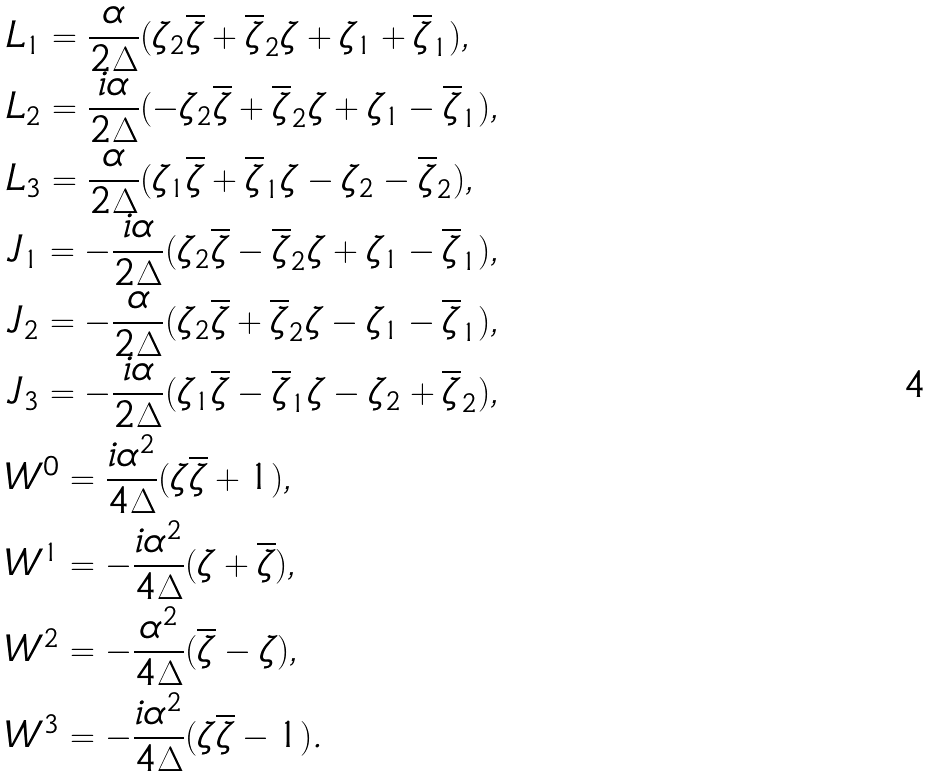<formula> <loc_0><loc_0><loc_500><loc_500>& L _ { 1 } = \frac { \alpha } { 2 \Delta } ( \zeta _ { 2 } \overline { \zeta } + \overline { \zeta } _ { 2 } \zeta + \zeta _ { 1 } + \overline { \zeta } _ { 1 } ) , \\ & L _ { 2 } = \frac { i \alpha } { 2 \Delta } ( - \zeta _ { 2 } \overline { \zeta } + \overline { \zeta } _ { 2 } \zeta + \zeta _ { 1 } - \overline { \zeta } _ { 1 } ) , \\ & L _ { 3 } = \frac { \alpha } { 2 \Delta } ( \zeta _ { 1 } \overline { \zeta } + \overline { \zeta } _ { 1 } \zeta - \zeta _ { 2 } - \overline { \zeta } _ { 2 } ) , \\ & J _ { 1 } = - \frac { i \alpha } { 2 \Delta } ( \zeta _ { 2 } \overline { \zeta } - \overline { \zeta } _ { 2 } \zeta + \zeta _ { 1 } - \overline { \zeta } _ { 1 } ) , \\ & J _ { 2 } = - \frac { \alpha } { 2 \Delta } ( \zeta _ { 2 } \overline { \zeta } + \overline { \zeta } _ { 2 } \zeta - \zeta _ { 1 } - \overline { \zeta } _ { 1 } ) , \\ & J _ { 3 } = - \frac { i \alpha } { 2 \Delta } ( \zeta _ { 1 } \overline { \zeta } - \overline { \zeta } _ { 1 } \zeta - \zeta _ { 2 } + \overline { \zeta } _ { 2 } ) , \\ & W ^ { 0 } = \frac { i \alpha ^ { 2 } } { 4 \Delta } ( \zeta \overline { \zeta } + 1 ) , \\ & W ^ { 1 } = - \frac { i \alpha ^ { 2 } } { 4 \Delta } ( \zeta + \overline { \zeta } ) , \\ & W ^ { 2 } = - \frac { \alpha ^ { 2 } } { 4 \Delta } ( \overline { \zeta } - \zeta ) , \\ & W ^ { 3 } = - \frac { i \alpha ^ { 2 } } { 4 \Delta } ( \zeta \overline { \zeta } - 1 ) .</formula> 